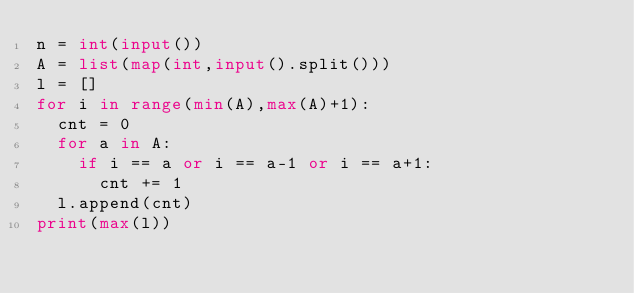<code> <loc_0><loc_0><loc_500><loc_500><_Python_>n = int(input())
A = list(map(int,input().split()))
l = []
for i in range(min(A),max(A)+1):
  cnt = 0
  for a in A:
    if i == a or i == a-1 or i == a+1:
      cnt += 1
  l.append(cnt)
print(max(l))
  </code> 